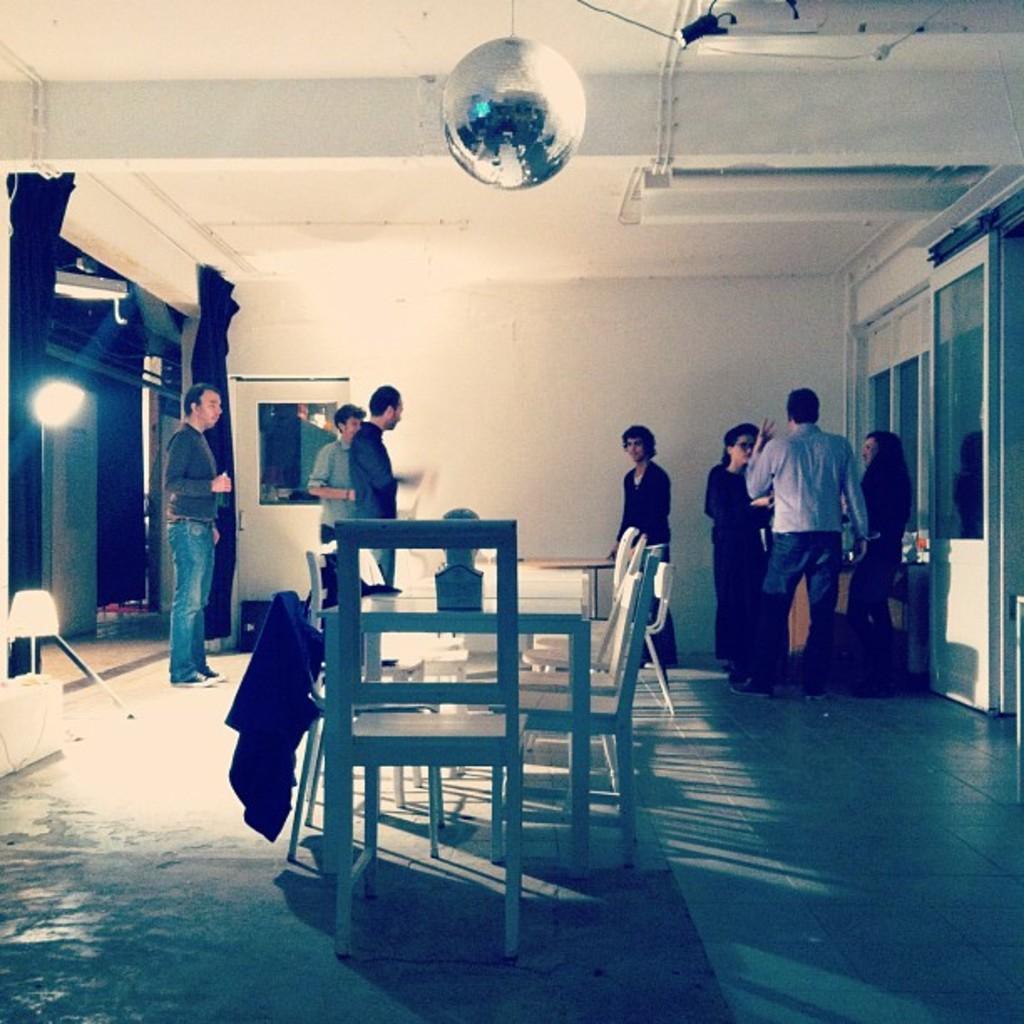Describe this image in one or two sentences. In this picture we can see a group of people standing and some are talking and in front of them there is tables, chairs and in background we can see wall, curtains, light, doors. 